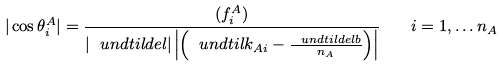Convert formula to latex. <formula><loc_0><loc_0><loc_500><loc_500>| \cos \theta ^ { A } _ { i } | = \frac { ( f ^ { A } _ { i } ) } { \left | \ u n d t i l d e l \right | \left | \left ( \ u n d t i l k _ { A i } - \frac { \ u n d t i l d e l b } { n _ { A } } \right ) \right | } \quad i = 1 , \dots n _ { A }</formula> 